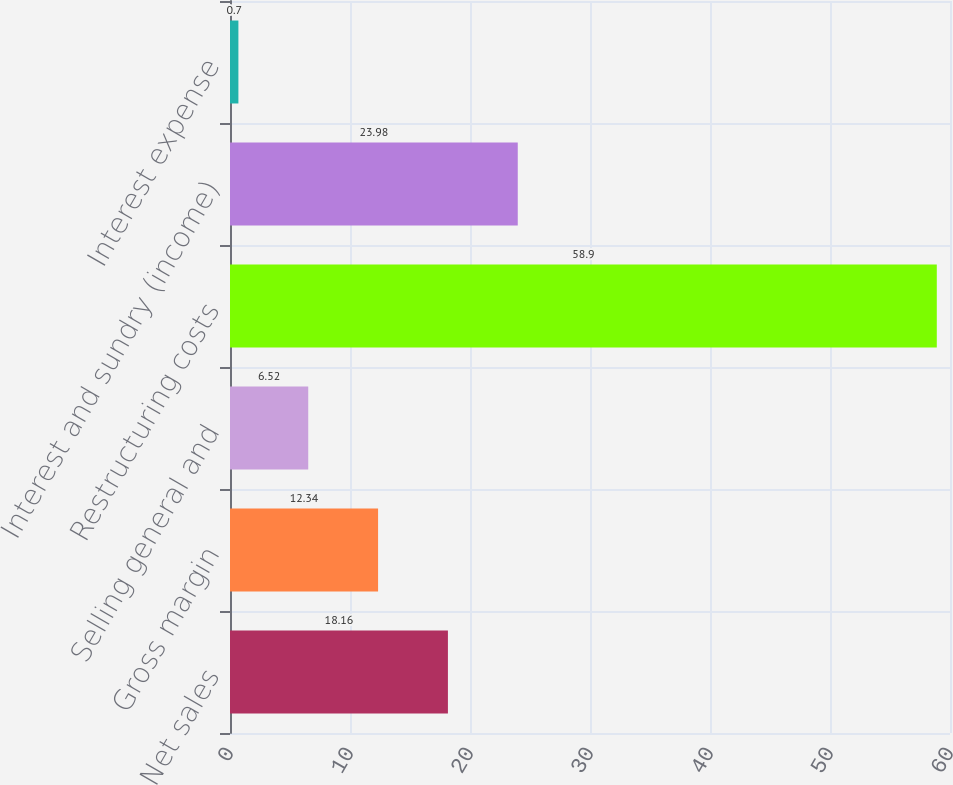Convert chart. <chart><loc_0><loc_0><loc_500><loc_500><bar_chart><fcel>Net sales<fcel>Gross margin<fcel>Selling general and<fcel>Restructuring costs<fcel>Interest and sundry (income)<fcel>Interest expense<nl><fcel>18.16<fcel>12.34<fcel>6.52<fcel>58.9<fcel>23.98<fcel>0.7<nl></chart> 